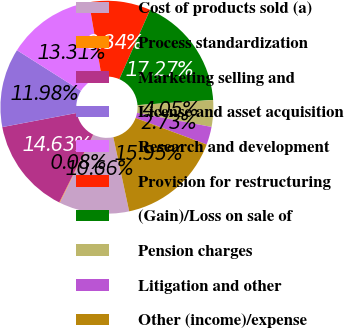<chart> <loc_0><loc_0><loc_500><loc_500><pie_chart><fcel>Cost of products sold (a)<fcel>Process standardization<fcel>Marketing selling and<fcel>License and asset acquisition<fcel>Research and development<fcel>Provision for restructuring<fcel>(Gain)/Loss on sale of<fcel>Pension charges<fcel>Litigation and other<fcel>Other (income)/expense<nl><fcel>10.66%<fcel>0.08%<fcel>14.63%<fcel>11.98%<fcel>13.31%<fcel>9.34%<fcel>17.27%<fcel>4.05%<fcel>2.73%<fcel>15.95%<nl></chart> 